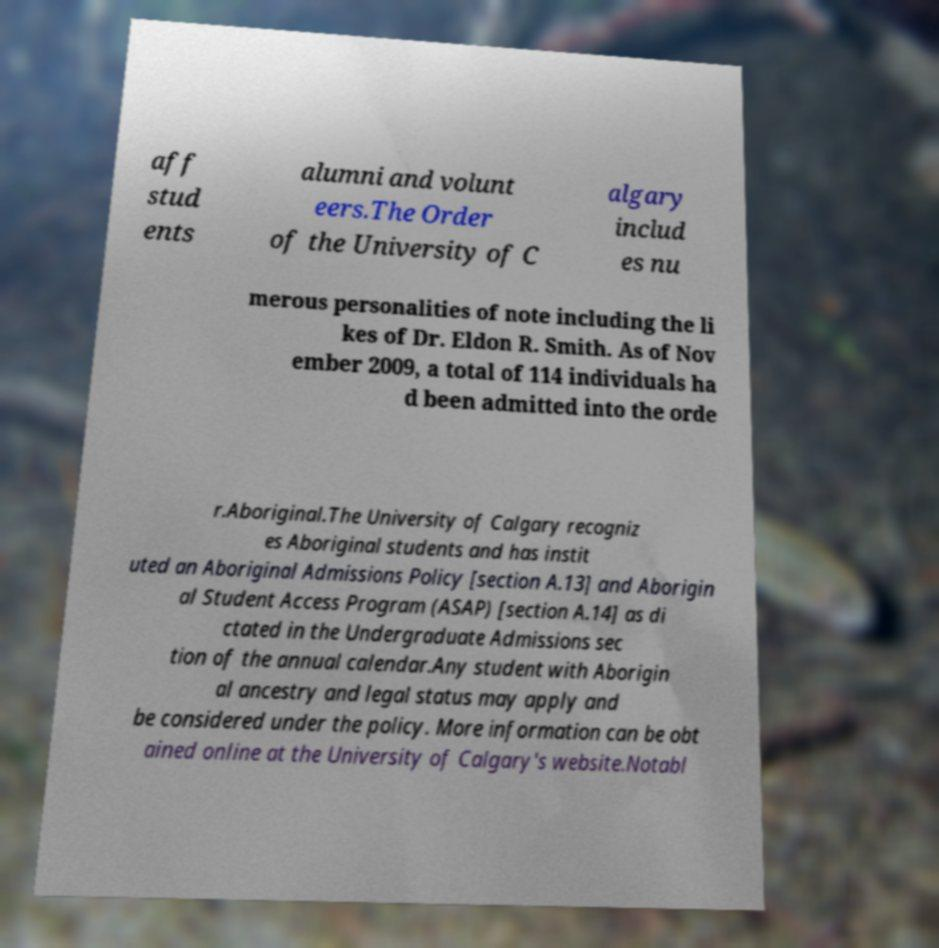Could you assist in decoding the text presented in this image and type it out clearly? aff stud ents alumni and volunt eers.The Order of the University of C algary includ es nu merous personalities of note including the li kes of Dr. Eldon R. Smith. As of Nov ember 2009, a total of 114 individuals ha d been admitted into the orde r.Aboriginal.The University of Calgary recogniz es Aboriginal students and has instit uted an Aboriginal Admissions Policy [section A.13] and Aborigin al Student Access Program (ASAP) [section A.14] as di ctated in the Undergraduate Admissions sec tion of the annual calendar.Any student with Aborigin al ancestry and legal status may apply and be considered under the policy. More information can be obt ained online at the University of Calgary's website.Notabl 